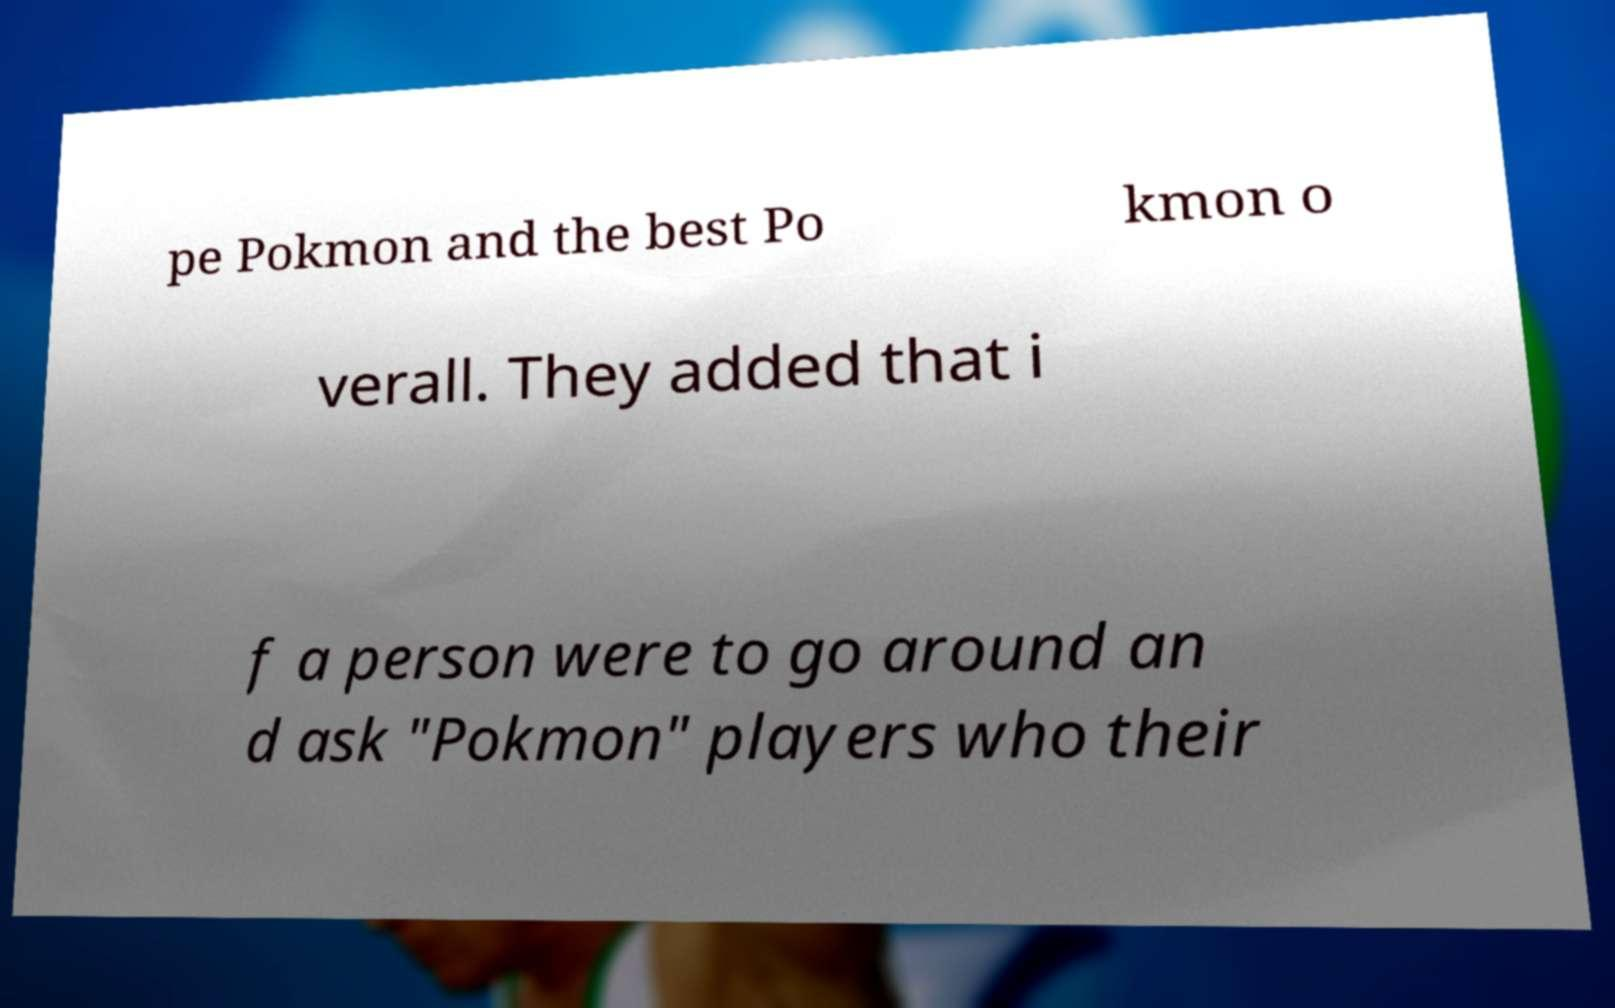Could you assist in decoding the text presented in this image and type it out clearly? pe Pokmon and the best Po kmon o verall. They added that i f a person were to go around an d ask "Pokmon" players who their 